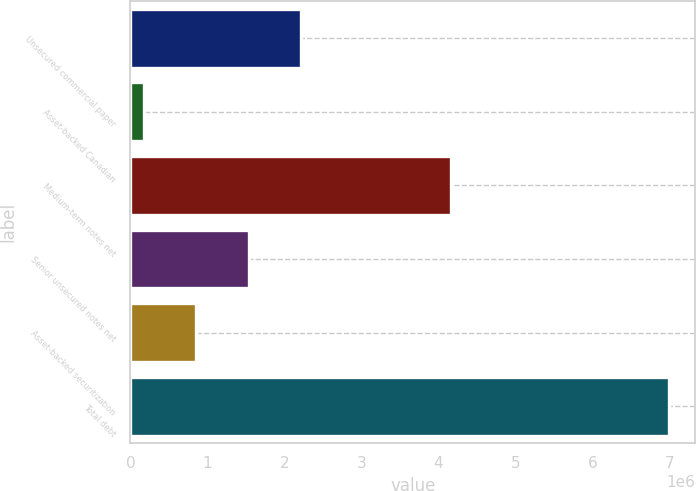<chart> <loc_0><loc_0><loc_500><loc_500><bar_chart><fcel>Unsecured commercial paper<fcel>Asset-backed Canadian<fcel>Medium-term notes net<fcel>Senior unsecured notes net<fcel>Asset-backed securitization<fcel>Total debt<nl><fcel>2.21875e+06<fcel>174779<fcel>4.16571e+06<fcel>1.53742e+06<fcel>856102<fcel>6.98801e+06<nl></chart> 